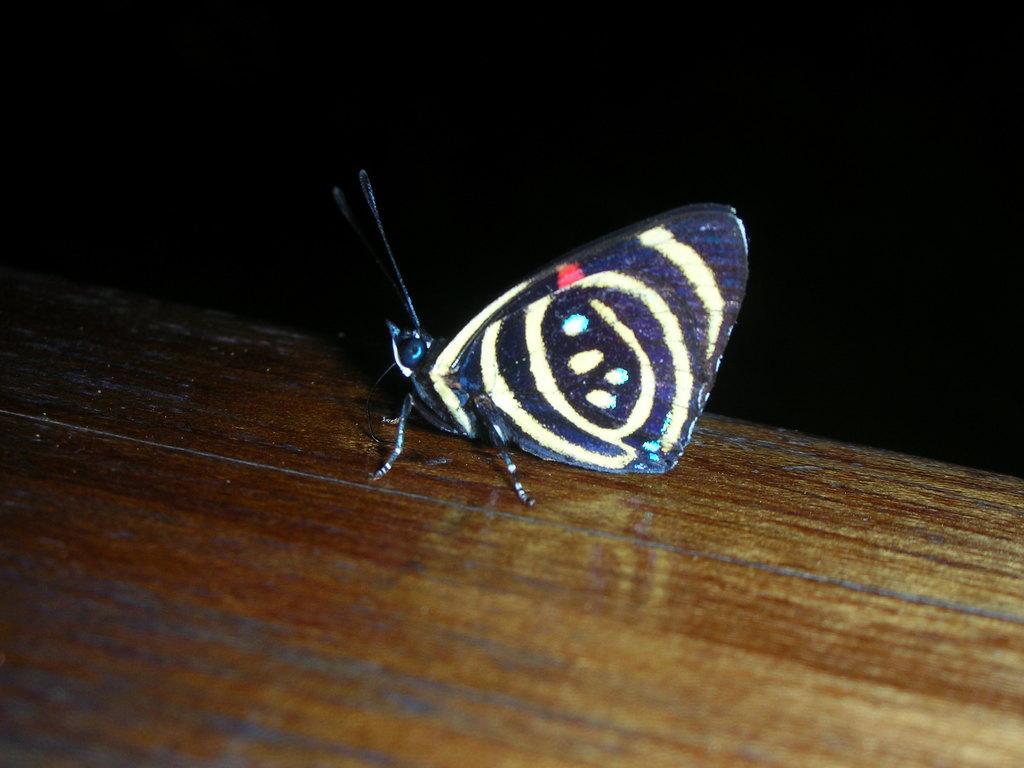Describe this image in one or two sentences. At the bottom of the image there is a wooden table. In the middle of the image there is a butterfly on the wooden table. In this image the background is dark. 